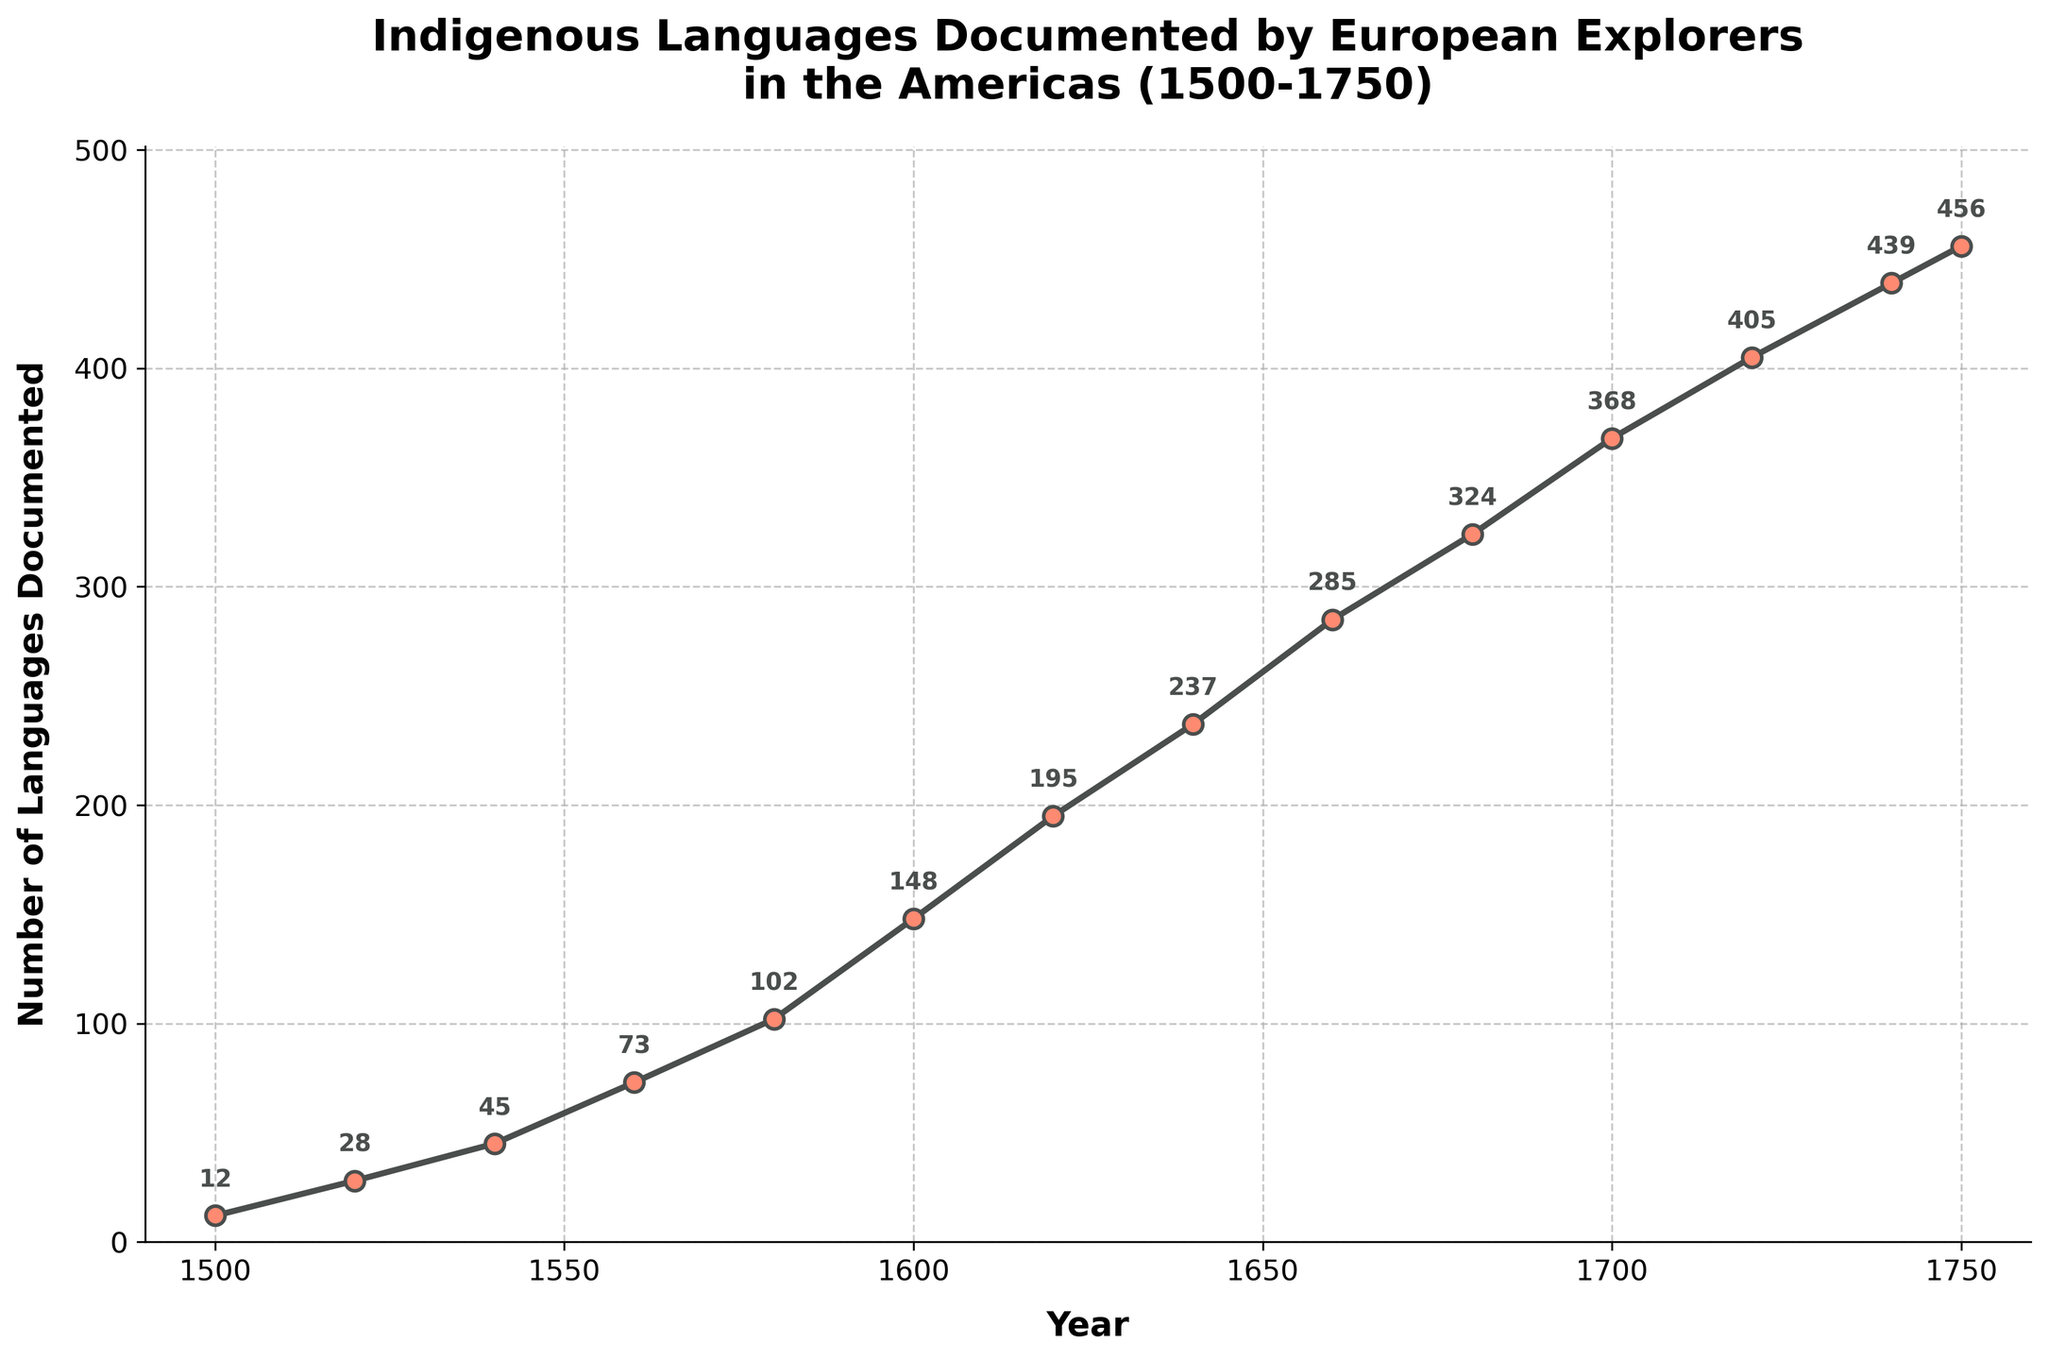What is the total increase in the number of languages documented from 1500 to 1750? First, identify the number of languages documented in 1500 and 1750, which are 12 and 456 respectively. Then, subtract the number in 1500 from that in 1750: 456 - 12 = 444
Answer: 444 Which two 20-year periods saw the greatest increase in the number of languages documented? To determine this, calculate the difference in the number of languages documented for each 20-year period and compare them. The periods 1580-1600 (46 languages) and 1640-1660 (48 languages) show the greatest increases.
Answer: 1580-1600 and 1640-1660 What is the average number of languages documented every 40 years between 1500 and 1700? Calculate the total number of languages documented in each 40-year period: [(1500-1540): 45 - 12 = 33, (1540-1580): 102 - 45 = 57, (1580-1620): 195 - 102 = 93, (1620-1660): 285 - 195 = 90] and then find the average: (33 + 57 + 93 + 90) / 4 = 68.25
Answer: 68.25 What visual elements indicate the data points on the plot? The data points are indicated by markers (small circles), and each marker is labeled with the corresponding number of languages documented.
Answer: Markers with labels What was the number of languages documented in the year 1640? Locate the marker at the year 1640 on the x-axis and observe the label. The label shows the number 237.
Answer: 237 How many years did it take for the documented languages to approximately double from the year 1600? Identify the number of languages in 1600 (148) and double it to get 296. Find the closest year where the languages documented exceed 296, which is 1660 with 285 languages.
Answer: 60 years By what percentage did the number of languages documented increase from 1700 to 1720? Calculate the absolute increase from 1700 (368) to 1720 (405): 405 - 368 = 37. Then, calculate the percentage increase: (37 / 368) * 100 ≈ 10.05%
Answer: 10.05% Which year between 1500 and 1750 shows the smallest increment in documented languages when compared to the previous recorded point? To find this, calculate the increments between each successive 20 years and identify the smallest one. The smallest increment is from 1740 to 1750, which is 456 - 439 = 17.
Answer: 1740 - 1750 Compare the slope of the line between 1520 to 1540 and 1720 to 1740. Which period has a steeper slope? The slope is calculated by the increase in languages divided by the number of years. For 1520-1540, the increase is 45 - 28 = 17 in 20 years, slope = 17/20 = 0.85. For 1720-1740, the increase is 439 - 405 = 34 in 20 years, slope = 34/20 = 1.7. The period 1720-1740 has a steeper slope.
Answer: 1720-1740 In which year does the number of documented languages first exceed 100? Locate the year where the documented languages number crosses 100 for the first time, which is between 1560 (73) and 1580 (102). Hence, it is 1580.
Answer: 1580 